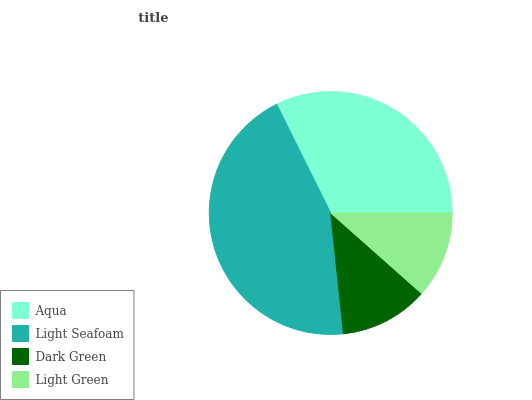Is Light Green the minimum?
Answer yes or no. Yes. Is Light Seafoam the maximum?
Answer yes or no. Yes. Is Dark Green the minimum?
Answer yes or no. No. Is Dark Green the maximum?
Answer yes or no. No. Is Light Seafoam greater than Dark Green?
Answer yes or no. Yes. Is Dark Green less than Light Seafoam?
Answer yes or no. Yes. Is Dark Green greater than Light Seafoam?
Answer yes or no. No. Is Light Seafoam less than Dark Green?
Answer yes or no. No. Is Aqua the high median?
Answer yes or no. Yes. Is Dark Green the low median?
Answer yes or no. Yes. Is Dark Green the high median?
Answer yes or no. No. Is Aqua the low median?
Answer yes or no. No. 